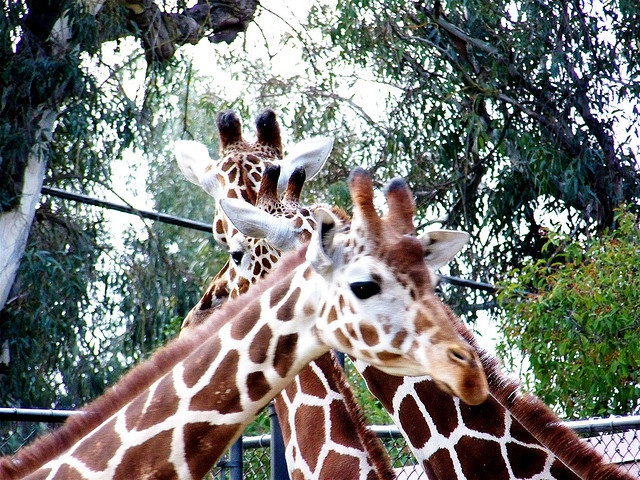Describe the objects in this image and their specific colors. I can see giraffe in black, white, brown, maroon, and darkgray tones, giraffe in black, lightgray, maroon, and darkgray tones, and giraffe in black, white, maroon, and brown tones in this image. 